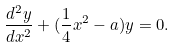Convert formula to latex. <formula><loc_0><loc_0><loc_500><loc_500>\frac { d ^ { 2 } y } { d x ^ { 2 } } + ( \frac { 1 } { 4 } x ^ { 2 } - a ) y = 0 .</formula> 